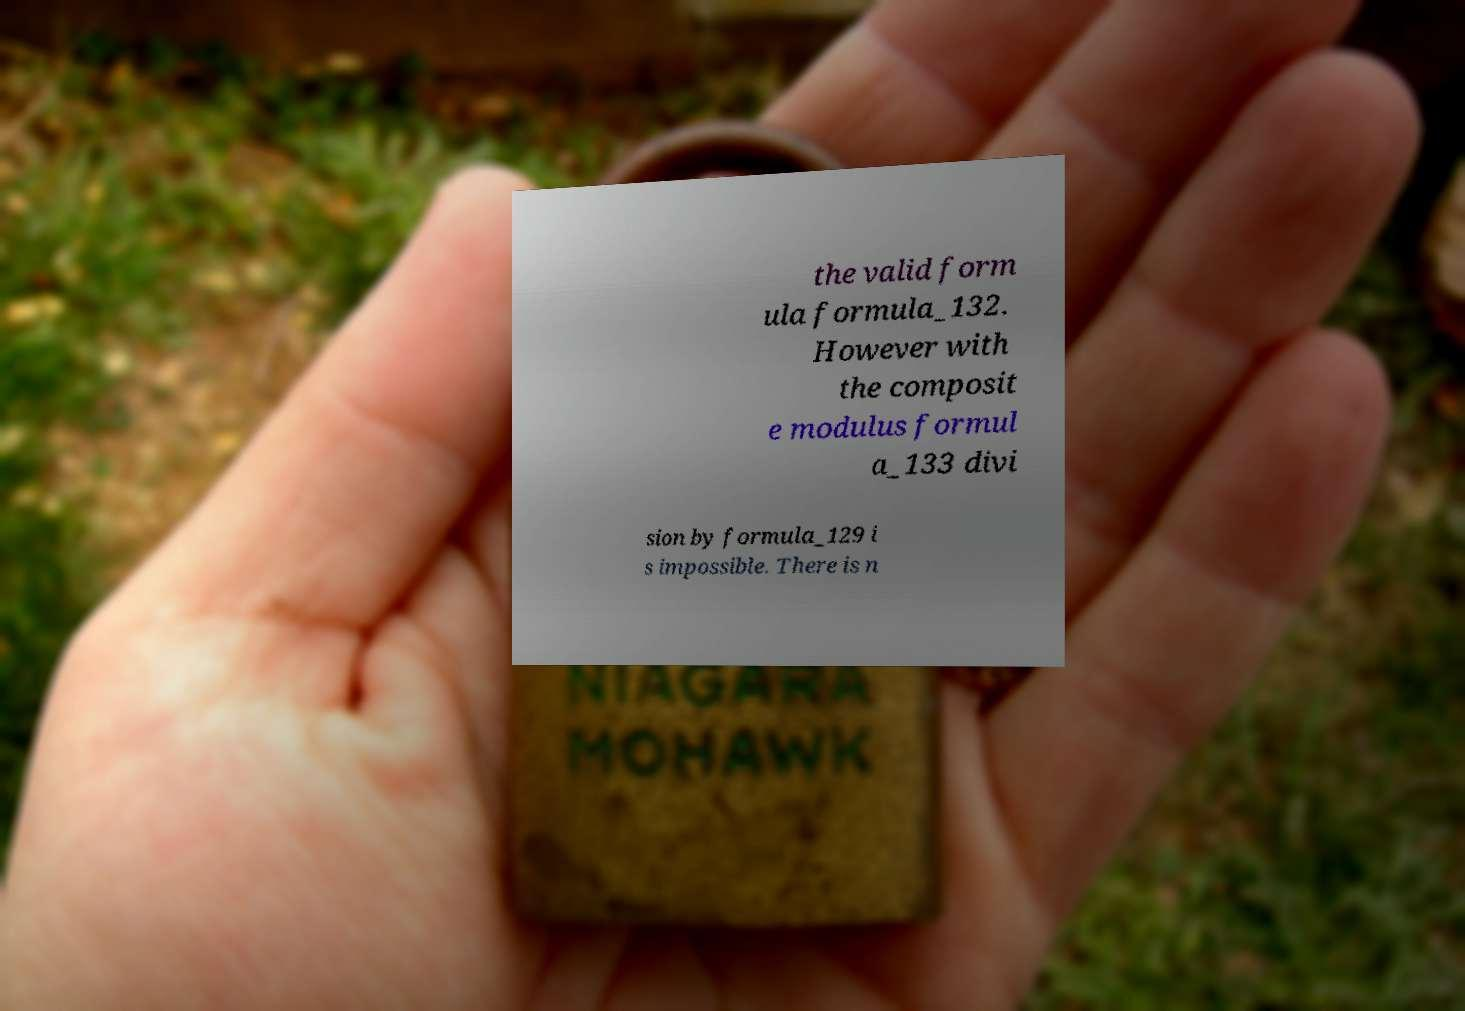Can you read and provide the text displayed in the image?This photo seems to have some interesting text. Can you extract and type it out for me? the valid form ula formula_132. However with the composit e modulus formul a_133 divi sion by formula_129 i s impossible. There is n 